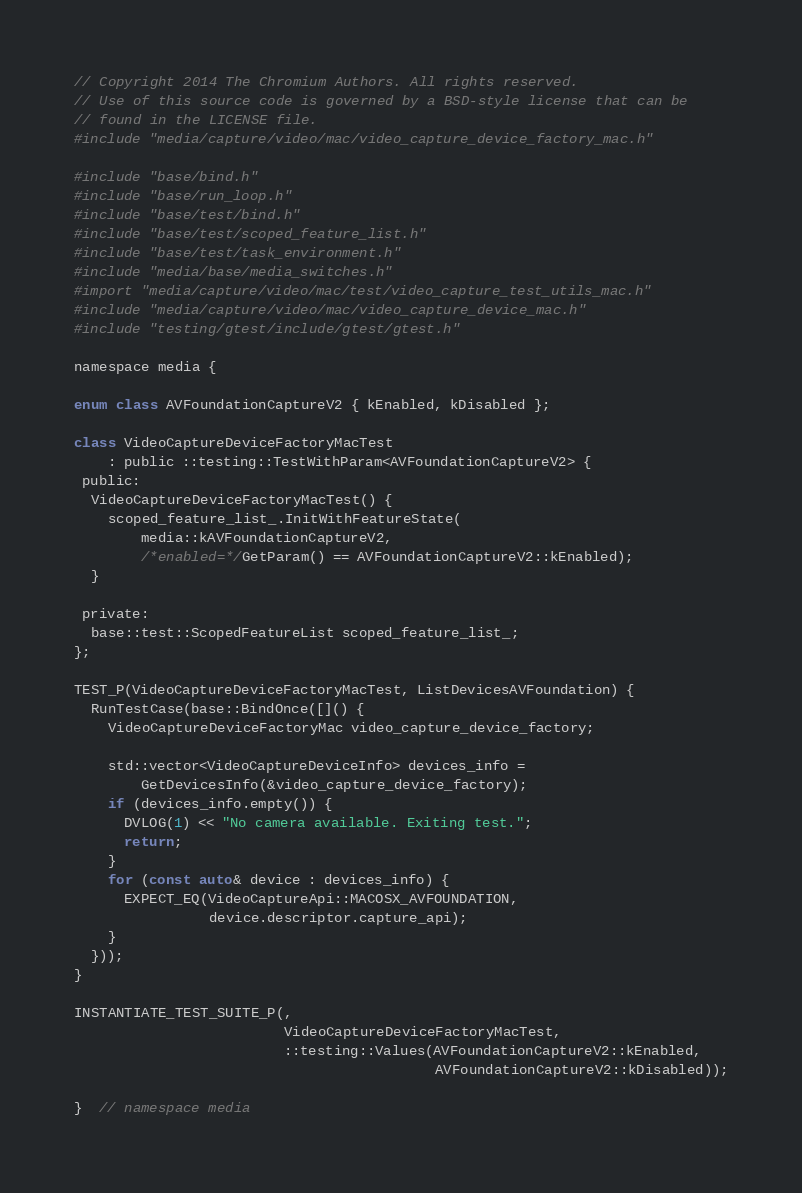Convert code to text. <code><loc_0><loc_0><loc_500><loc_500><_ObjectiveC_>// Copyright 2014 The Chromium Authors. All rights reserved.
// Use of this source code is governed by a BSD-style license that can be
// found in the LICENSE file.
#include "media/capture/video/mac/video_capture_device_factory_mac.h"

#include "base/bind.h"
#include "base/run_loop.h"
#include "base/test/bind.h"
#include "base/test/scoped_feature_list.h"
#include "base/test/task_environment.h"
#include "media/base/media_switches.h"
#import "media/capture/video/mac/test/video_capture_test_utils_mac.h"
#include "media/capture/video/mac/video_capture_device_mac.h"
#include "testing/gtest/include/gtest/gtest.h"

namespace media {

enum class AVFoundationCaptureV2 { kEnabled, kDisabled };

class VideoCaptureDeviceFactoryMacTest
    : public ::testing::TestWithParam<AVFoundationCaptureV2> {
 public:
  VideoCaptureDeviceFactoryMacTest() {
    scoped_feature_list_.InitWithFeatureState(
        media::kAVFoundationCaptureV2,
        /*enabled=*/GetParam() == AVFoundationCaptureV2::kEnabled);
  }

 private:
  base::test::ScopedFeatureList scoped_feature_list_;
};

TEST_P(VideoCaptureDeviceFactoryMacTest, ListDevicesAVFoundation) {
  RunTestCase(base::BindOnce([]() {
    VideoCaptureDeviceFactoryMac video_capture_device_factory;

    std::vector<VideoCaptureDeviceInfo> devices_info =
        GetDevicesInfo(&video_capture_device_factory);
    if (devices_info.empty()) {
      DVLOG(1) << "No camera available. Exiting test.";
      return;
    }
    for (const auto& device : devices_info) {
      EXPECT_EQ(VideoCaptureApi::MACOSX_AVFOUNDATION,
                device.descriptor.capture_api);
    }
  }));
}

INSTANTIATE_TEST_SUITE_P(,
                         VideoCaptureDeviceFactoryMacTest,
                         ::testing::Values(AVFoundationCaptureV2::kEnabled,
                                           AVFoundationCaptureV2::kDisabled));

}  // namespace media
</code> 